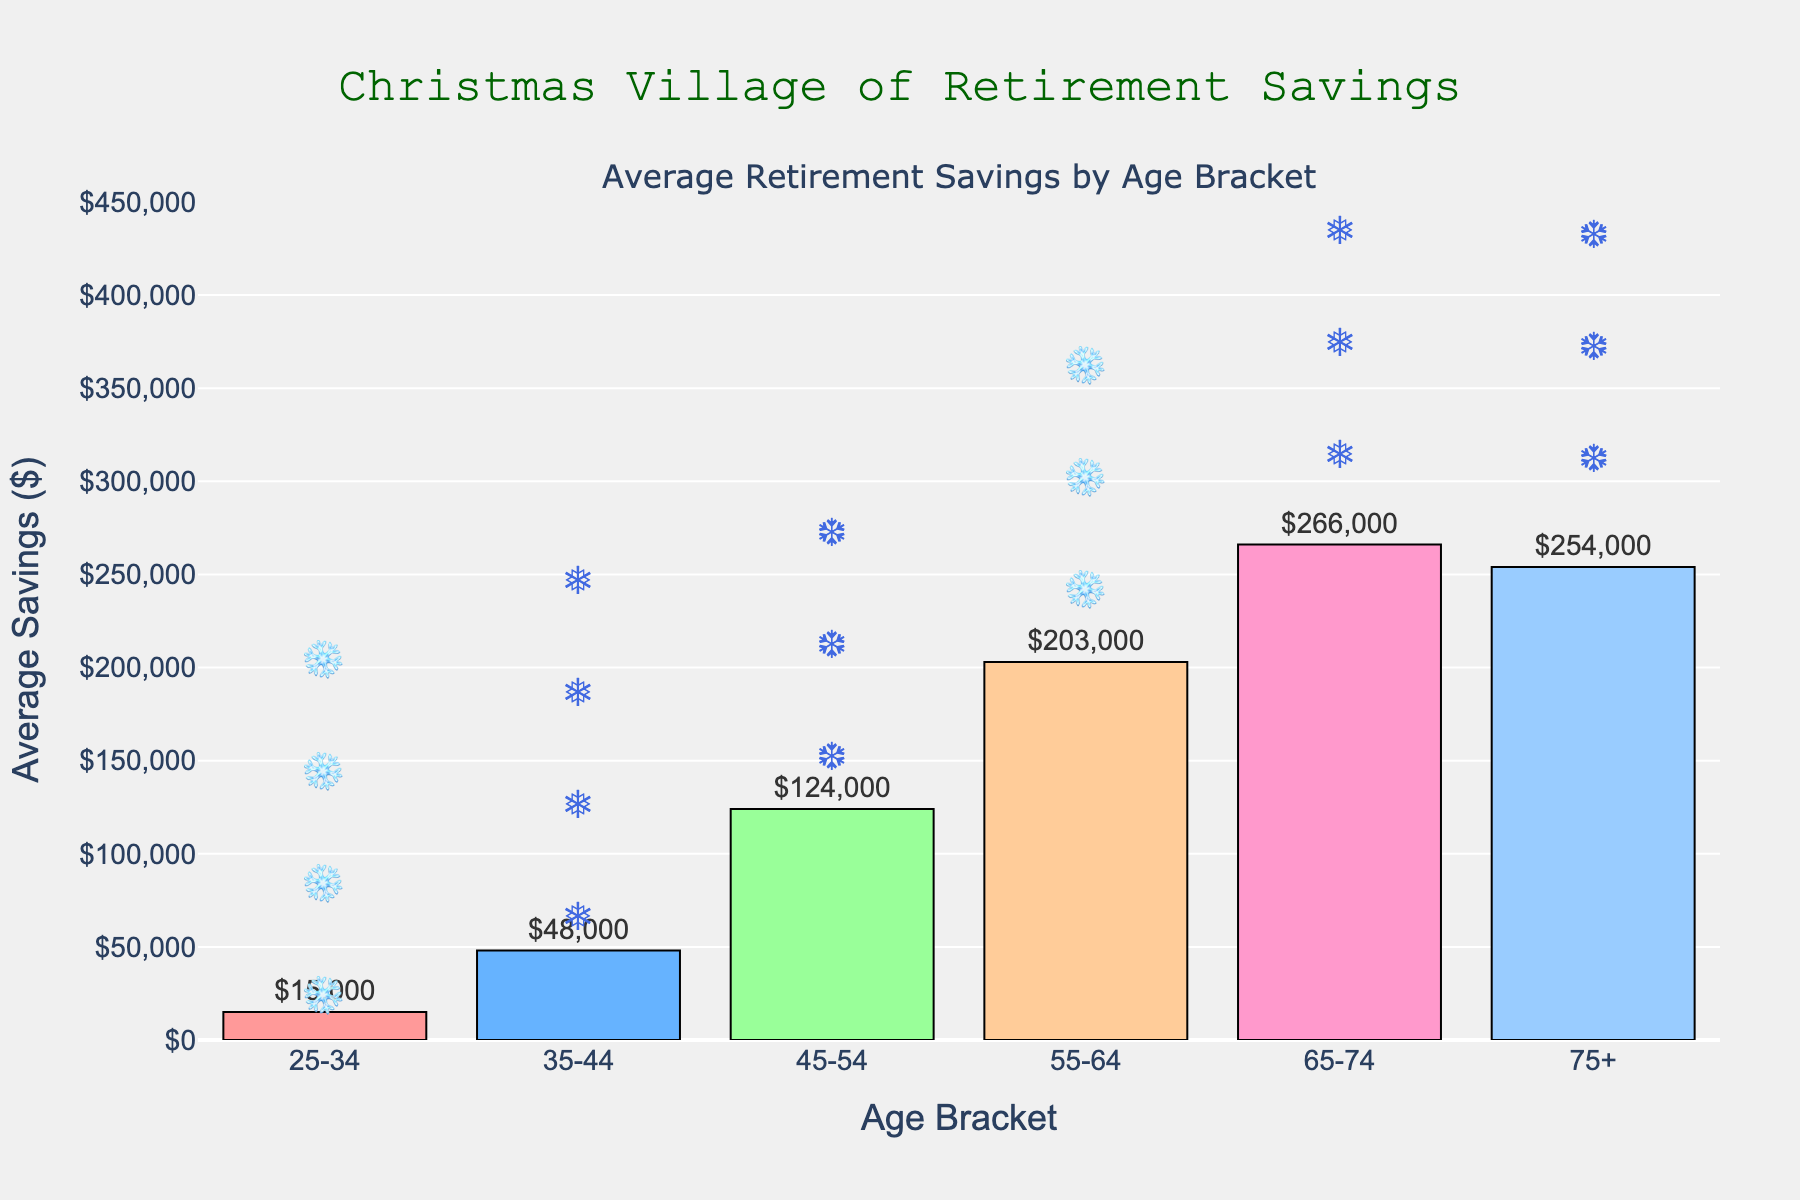What is the average retirement savings for the 45-54 age bracket? Look at the bar corresponding to the 45-54 age bracket and read the value.
Answer: $124,000 Which age bracket has the highest average retirement savings? Compare the heights of the bars and identify the tallest one.
Answer: 65-74 How much more are the average retirement savings for the 55-64 age bracket compared to the 35-44 age bracket? Subtract the savings for the 35-44 age bracket from the savings for the 55-64 age bracket: 203,000 - 48,000.
Answer: $155,000 What is the difference in savings between the age brackets 45-54 and 75+? Subtract the savings for the 75+ age bracket from the savings for the 45-54 age bracket: 254,000 - 124,000.
Answer: $130,000 Which age bracket has the lowest average retirement savings? Compare the heights of the bars and identify the shortest one.
Answer: 25-34 What is the total average retirement savings for all the age brackets combined? Add the values for all age brackets: 15,000 + 48,000 + 124,000 + 203,000 + 266,000 + 254,000.
Answer: $910,000 How much higher are the average retirement savings for the 65-74 age bracket compared to the 25-34 age bracket? Subtract the savings for the 25-34 age bracket from the savings for the 65-74 age bracket: 266,000 - 15,000.
Answer: $251,000 Which age bracket has approximately double the average retirement savings of the 35-44 age bracket? The 35-44 age bracket has $48,000. Find an age bracket with approximately double that amount: 48,000 x 2 ≈ 96,000. The 45-54 age bracket has $124,000.
Answer: 45-54 How do the average retirement savings of the 55-64 and 75+ age brackets compare? Compare the values: 203,000 for 55-64 and 254,000 for 75+.
Answer: 75+ is higher Estimate the average retirement savings across age brackets 35-44, 45-54, and 55-64. Calculate the average of the three values: (48,000 + 124,000 + 203,000) / 3.
Answer: $125,000 